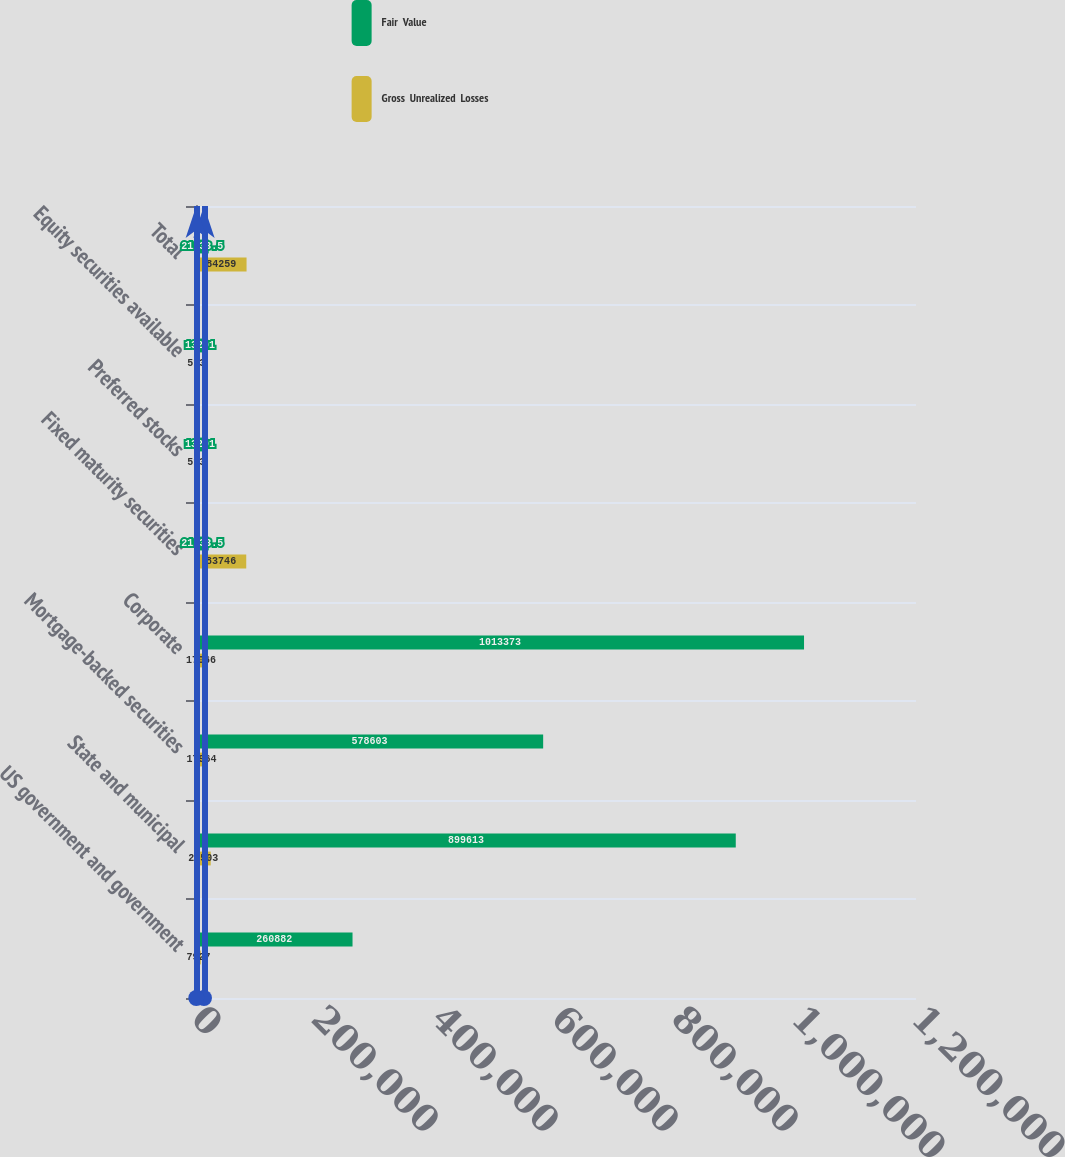<chart> <loc_0><loc_0><loc_500><loc_500><stacked_bar_chart><ecel><fcel>US government and government<fcel>State and municipal<fcel>Mortgage-backed securities<fcel>Corporate<fcel>Fixed maturity securities<fcel>Preferred stocks<fcel>Equity securities available<fcel>Total<nl><fcel>Fair  Value<fcel>260882<fcel>899613<fcel>578603<fcel>1.01337e+06<fcel>21233.5<fcel>13291<fcel>13291<fcel>21233.5<nl><fcel>Gross  Unrealized  Losses<fcel>7927<fcel>24503<fcel>17964<fcel>17066<fcel>83746<fcel>513<fcel>513<fcel>84259<nl></chart> 